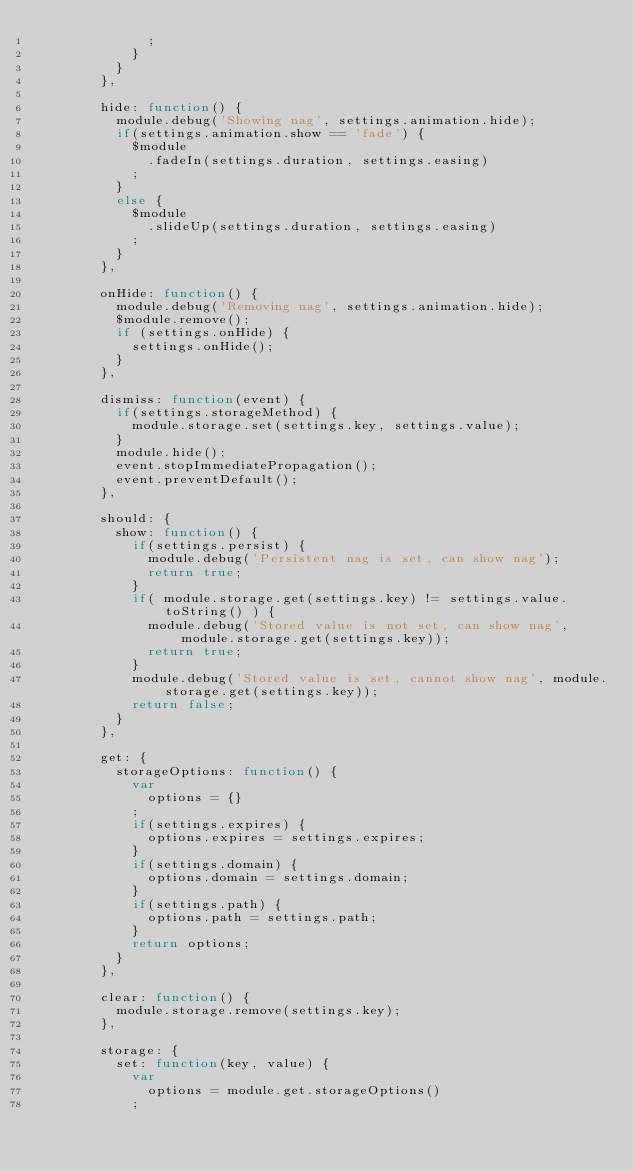Convert code to text. <code><loc_0><loc_0><loc_500><loc_500><_JavaScript_>              ;
            }
          }
        },

        hide: function() {
          module.debug('Showing nag', settings.animation.hide);
          if(settings.animation.show == 'fade') {
            $module
              .fadeIn(settings.duration, settings.easing)
            ;
          }
          else {
            $module
              .slideUp(settings.duration, settings.easing)
            ;
          }
        },

        onHide: function() {
          module.debug('Removing nag', settings.animation.hide);
          $module.remove();
          if (settings.onHide) {
            settings.onHide();
          }
        },

        dismiss: function(event) {
          if(settings.storageMethod) {
            module.storage.set(settings.key, settings.value);
          }
          module.hide();
          event.stopImmediatePropagation();
          event.preventDefault();
        },

        should: {
          show: function() {
            if(settings.persist) {
              module.debug('Persistent nag is set, can show nag');
              return true;
            }
            if( module.storage.get(settings.key) != settings.value.toString() ) {
              module.debug('Stored value is not set, can show nag', module.storage.get(settings.key));
              return true;
            }
            module.debug('Stored value is set, cannot show nag', module.storage.get(settings.key));
            return false;
          }
        },

        get: {
          storageOptions: function() {
            var
              options = {}
            ;
            if(settings.expires) {
              options.expires = settings.expires;
            }
            if(settings.domain) {
              options.domain = settings.domain;
            }
            if(settings.path) {
              options.path = settings.path;
            }
            return options;
          }
        },

        clear: function() {
          module.storage.remove(settings.key);
        },

        storage: {
          set: function(key, value) {
            var
              options = module.get.storageOptions()
            ;</code> 